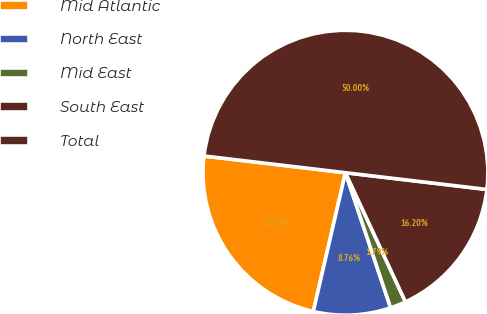Convert chart. <chart><loc_0><loc_0><loc_500><loc_500><pie_chart><fcel>Mid Atlantic<fcel>North East<fcel>Mid East<fcel>South East<fcel>Total<nl><fcel>23.25%<fcel>8.76%<fcel>1.79%<fcel>16.2%<fcel>50.0%<nl></chart> 